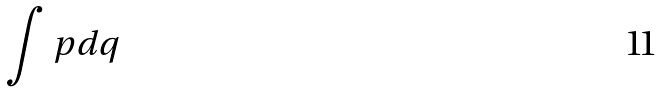<formula> <loc_0><loc_0><loc_500><loc_500>\int p d q</formula> 